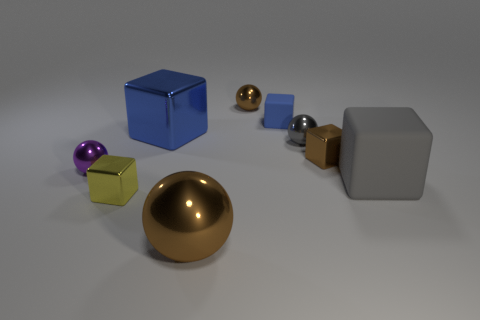Add 1 tiny red rubber things. How many objects exist? 10 Subtract 1 purple spheres. How many objects are left? 8 Subtract all balls. How many objects are left? 5 Subtract 4 balls. How many balls are left? 0 Subtract all purple blocks. Subtract all yellow cylinders. How many blocks are left? 5 Subtract all purple cubes. How many cyan spheres are left? 0 Subtract all tiny green blocks. Subtract all rubber blocks. How many objects are left? 7 Add 4 cubes. How many cubes are left? 9 Add 9 tiny blue metallic balls. How many tiny blue metallic balls exist? 9 Subtract all gray blocks. How many blocks are left? 4 